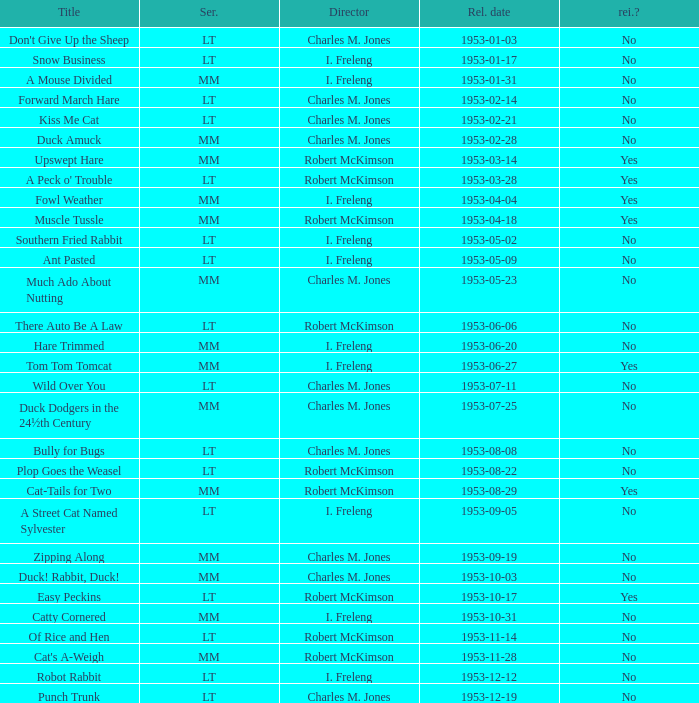What's the release date of Forward March Hare? 1953-02-14. 